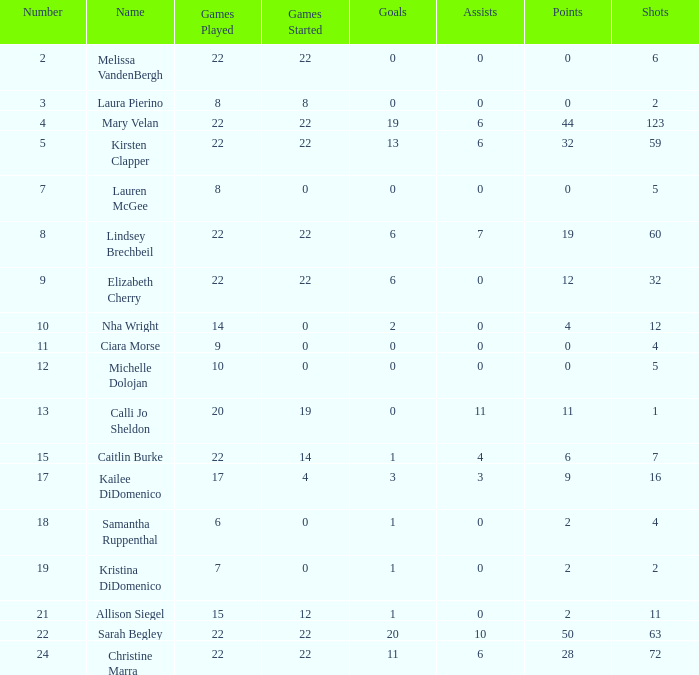How many games played catagories are there for Lauren McGee?  1.0. 